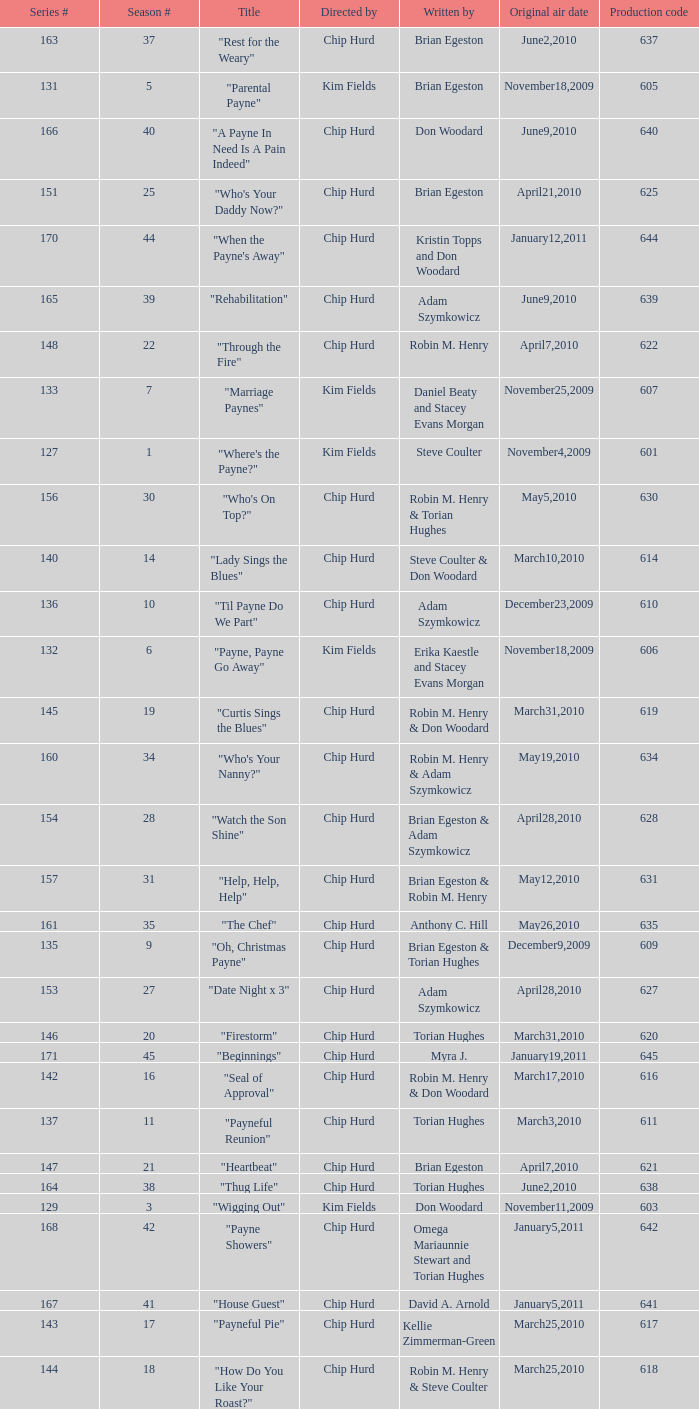What is the original air dates for the title "firestorm"? March31,2010. 